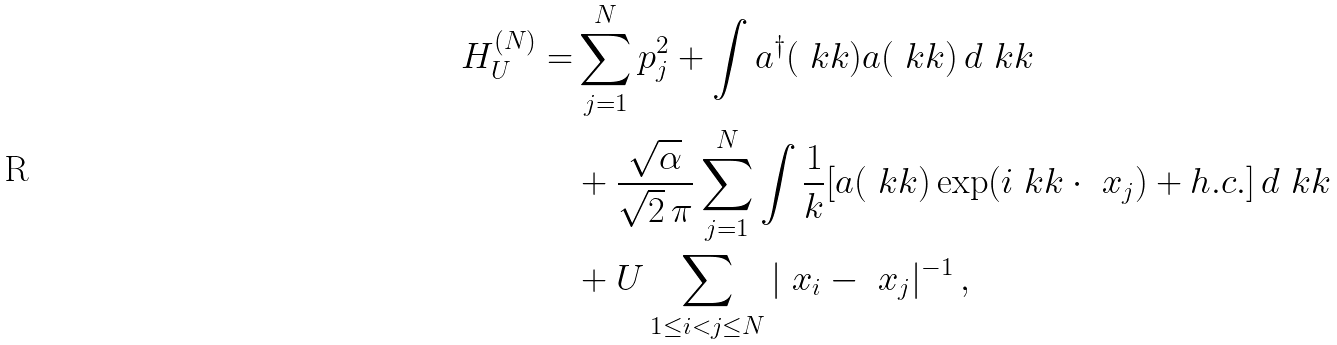Convert formula to latex. <formula><loc_0><loc_0><loc_500><loc_500>H ^ { ( N ) } _ { U } = & \sum _ { j = 1 } ^ { N } p _ { j } ^ { 2 } + \int a ^ { \dagger } ( \ k k ) a ( \ k k ) \, d \ k k \\ & + \frac { \sqrt { \alpha } } { \sqrt { 2 } \, \pi } \sum _ { j = 1 } ^ { N } \int \frac { 1 } { k } [ a ( \ k k ) \exp ( i \ k k \cdot \ x _ { j } ) + h . c . ] \, d \ k k \\ & + U \sum _ { 1 \leq i < j \leq N } | \ x _ { i } - \ x _ { j } | ^ { - 1 } \, ,</formula> 